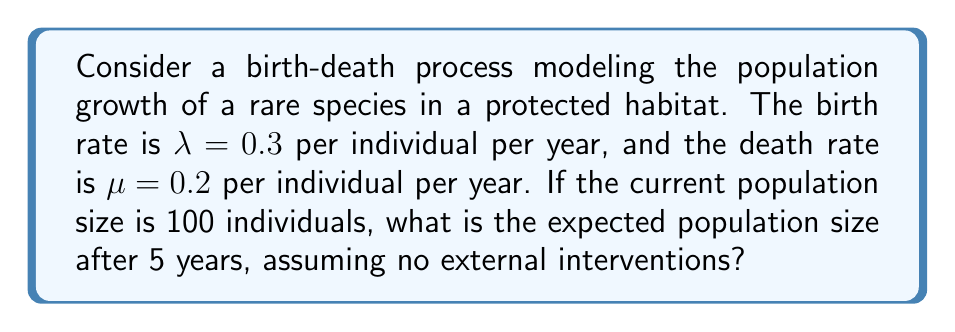Teach me how to tackle this problem. To solve this problem, we'll use the following steps:

1) In a birth-death process, the net growth rate is given by $r = \lambda - \mu$.

2) Here, $r = 0.3 - 0.2 = 0.1$ per individual per year.

3) For a population with initial size $N_0$ and net growth rate $r$, the expected population size at time $t$ is given by the exponential growth model:

   $$N(t) = N_0 e^{rt}$$

4) In this case:
   - $N_0 = 100$ (initial population)
   - $r = 0.1$ (net growth rate)
   - $t = 5$ years

5) Substituting these values into the equation:

   $$N(5) = 100 e^{0.1 \times 5}$$

6) Simplifying:
   $$N(5) = 100 e^{0.5} \approx 164.87$$

7) Therefore, the expected population size after 5 years is approximately 165 individuals (rounding to the nearest whole number).
Answer: 165 individuals 